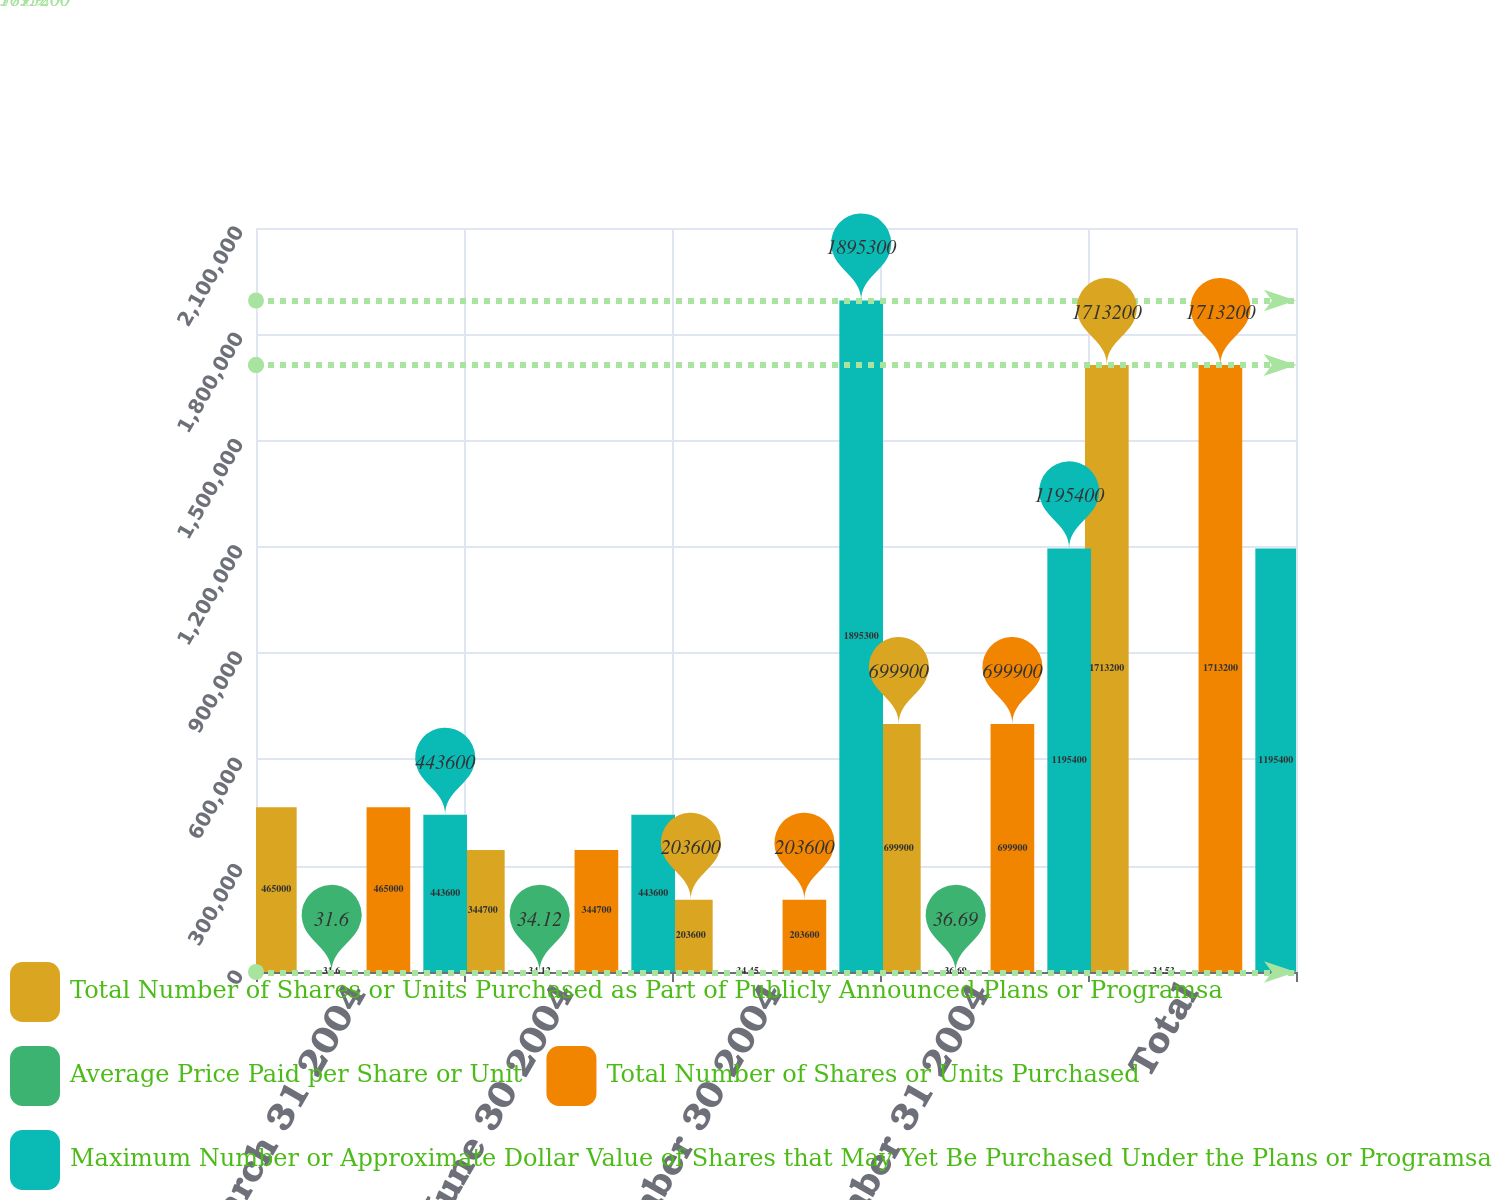Convert chart. <chart><loc_0><loc_0><loc_500><loc_500><stacked_bar_chart><ecel><fcel>March 31 2004<fcel>June 30 2004<fcel>September 30 2004<fcel>December 31 2004<fcel>Total<nl><fcel>Total Number of Shares or Units Purchased as Part of Publicly Announced Plans or Programsa<fcel>465000<fcel>344700<fcel>203600<fcel>699900<fcel>1.7132e+06<nl><fcel>Average Price Paid per Share or Unit<fcel>31.6<fcel>34.12<fcel>34.45<fcel>36.69<fcel>34.53<nl><fcel>Total Number of Shares or Units Purchased<fcel>465000<fcel>344700<fcel>203600<fcel>699900<fcel>1.7132e+06<nl><fcel>Maximum Number or Approximate Dollar Value of Shares that May Yet Be Purchased Under the Plans or Programsa<fcel>443600<fcel>443600<fcel>1.8953e+06<fcel>1.1954e+06<fcel>1.1954e+06<nl></chart> 